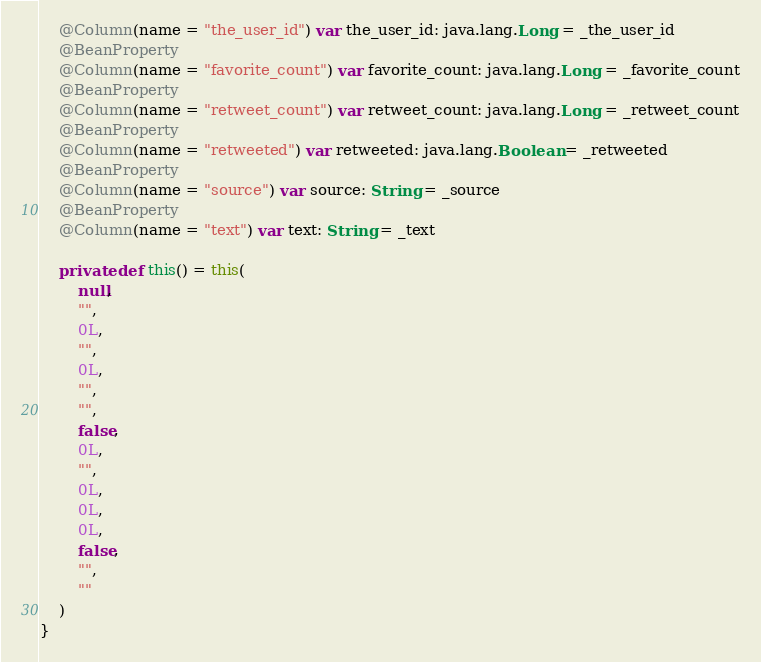Convert code to text. <code><loc_0><loc_0><loc_500><loc_500><_Scala_>    @Column(name = "the_user_id") var the_user_id: java.lang.Long = _the_user_id
    @BeanProperty
    @Column(name = "favorite_count") var favorite_count: java.lang.Long = _favorite_count
    @BeanProperty
    @Column(name = "retweet_count") var retweet_count: java.lang.Long = _retweet_count
    @BeanProperty
    @Column(name = "retweeted") var retweeted: java.lang.Boolean = _retweeted
    @BeanProperty
    @Column(name = "source") var source: String = _source
    @BeanProperty
    @Column(name = "text") var text: String = _text

    private def this() = this(
        null,
        "",
        0L,
        "",
        0L,
        "",
        "",
        false,
        0L,
        "",
        0L,
        0L,
        0L,
        false,
        "",
        ""
    )
}</code> 